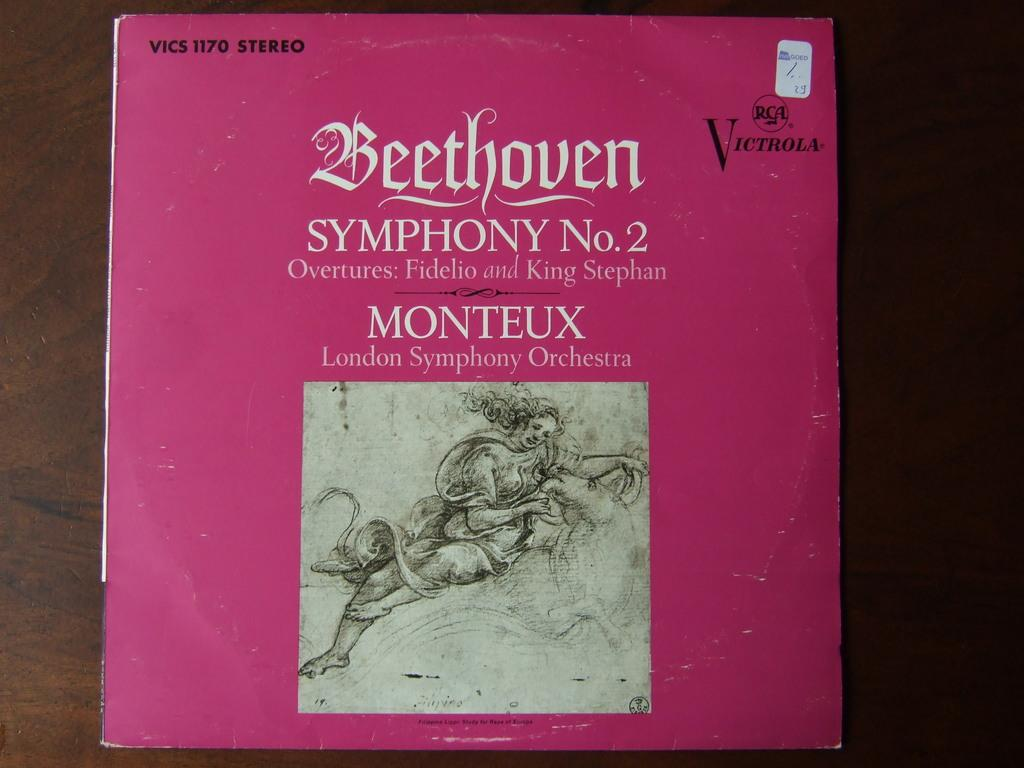<image>
Summarize the visual content of the image. A pink vinyl record that says Beethoven Symphony No. 2. 